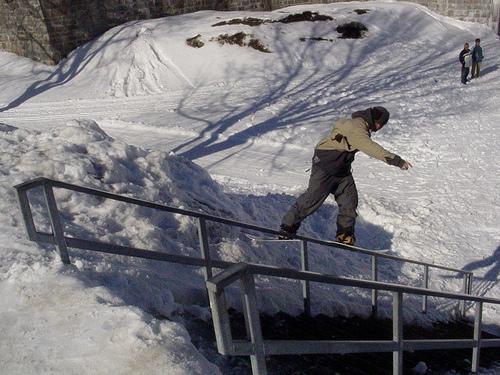What move is the snowboarder doing?
Select the accurate answer and provide justification: `Answer: choice
Rationale: srationale.`
Options: Grind, nose grab, kickflip, indy. Answer: grind.
Rationale: This snowboarder travels down the bannister on the bottom of his board. this is known as grinding in extreme sports. 